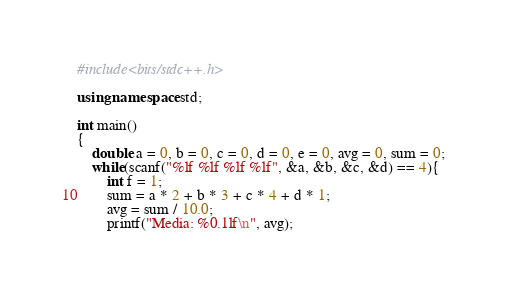<code> <loc_0><loc_0><loc_500><loc_500><_C++_>#include<bits/stdc++.h>

using namespace std;

int main()
{
    double a = 0, b = 0, c = 0, d = 0, e = 0, avg = 0, sum = 0;
    while(scanf("%lf %lf %lf %lf", &a, &b, &c, &d) == 4){
        int f = 1;
        sum = a * 2 + b * 3 + c * 4 + d * 1;
        avg = sum / 10.0;
        printf("Media: %0.1lf\n", avg);
</code> 